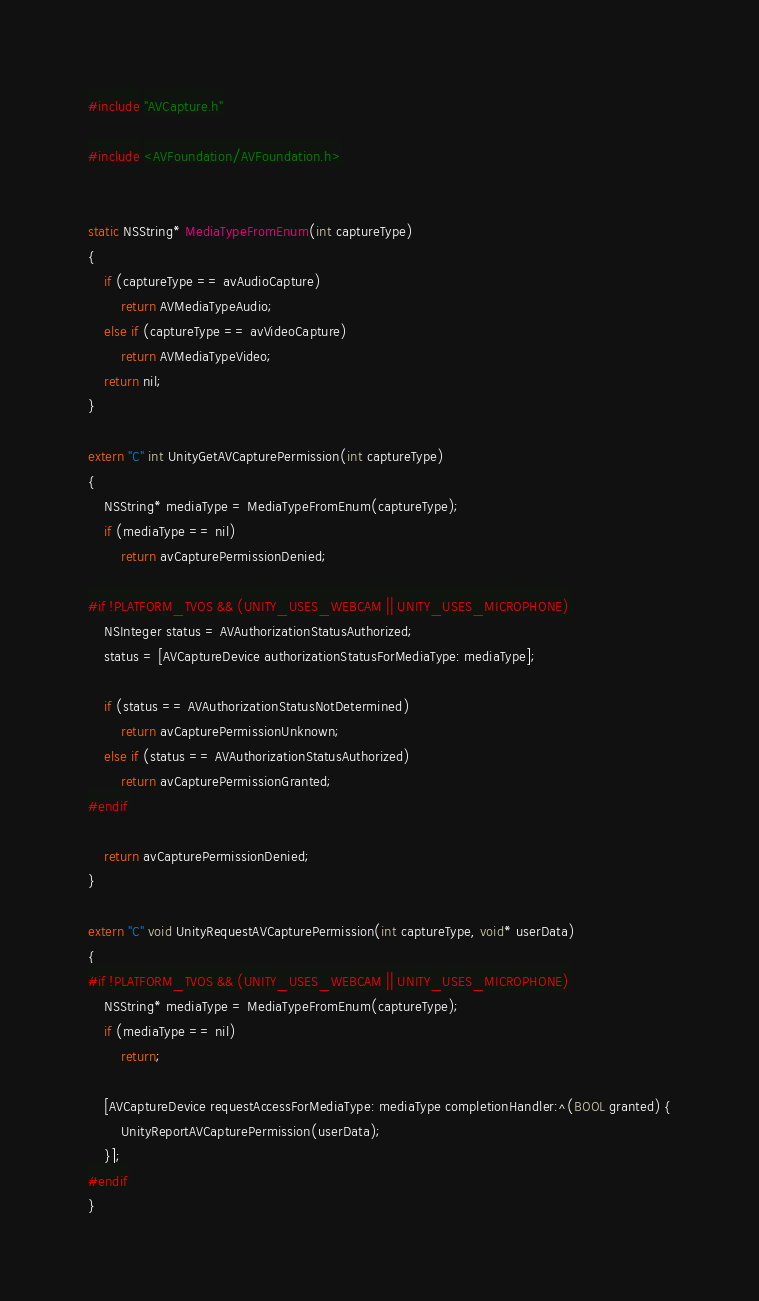<code> <loc_0><loc_0><loc_500><loc_500><_ObjectiveC_>#include "AVCapture.h"

#include <AVFoundation/AVFoundation.h>


static NSString* MediaTypeFromEnum(int captureType)
{
    if (captureType == avAudioCapture)
        return AVMediaTypeAudio;
    else if (captureType == avVideoCapture)
        return AVMediaTypeVideo;
    return nil;
}

extern "C" int UnityGetAVCapturePermission(int captureType)
{
    NSString* mediaType = MediaTypeFromEnum(captureType);
    if (mediaType == nil)
        return avCapturePermissionDenied;

#if !PLATFORM_TVOS && (UNITY_USES_WEBCAM || UNITY_USES_MICROPHONE)
    NSInteger status = AVAuthorizationStatusAuthorized;
    status = [AVCaptureDevice authorizationStatusForMediaType: mediaType];

    if (status == AVAuthorizationStatusNotDetermined)
        return avCapturePermissionUnknown;
    else if (status == AVAuthorizationStatusAuthorized)
        return avCapturePermissionGranted;
#endif

    return avCapturePermissionDenied;
}

extern "C" void UnityRequestAVCapturePermission(int captureType, void* userData)
{
#if !PLATFORM_TVOS && (UNITY_USES_WEBCAM || UNITY_USES_MICROPHONE)
    NSString* mediaType = MediaTypeFromEnum(captureType);
    if (mediaType == nil)
        return;

    [AVCaptureDevice requestAccessForMediaType: mediaType completionHandler:^(BOOL granted) {
        UnityReportAVCapturePermission(userData);
    }];
#endif
}
</code> 